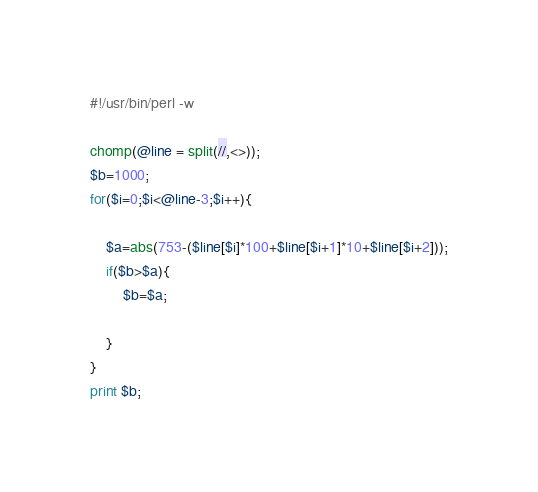<code> <loc_0><loc_0><loc_500><loc_500><_Perl_>#!/usr/bin/perl -w

chomp(@line = split(//,<>));
$b=1000;
for($i=0;$i<@line-3;$i++){
    
    $a=abs(753-($line[$i]*100+$line[$i+1]*10+$line[$i+2]));
    if($b>$a){
        $b=$a;
        
    }
}
print $b;</code> 